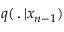Convert formula to latex. <formula><loc_0><loc_0><loc_500><loc_500>q ( \, . \, | x _ { n - 1 } )</formula> 